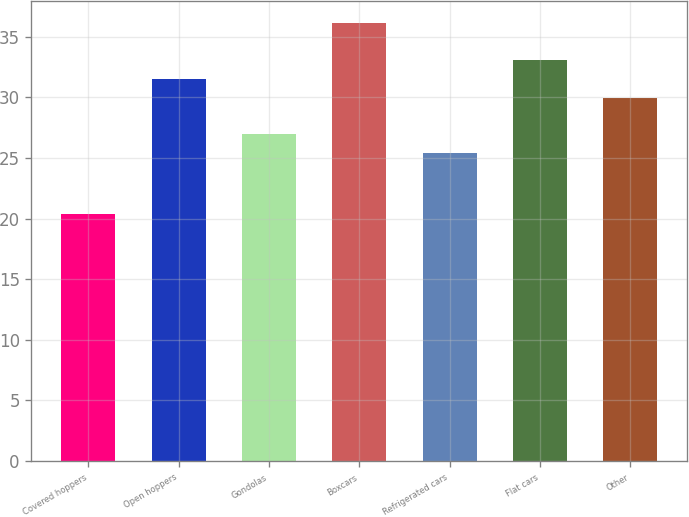Convert chart. <chart><loc_0><loc_0><loc_500><loc_500><bar_chart><fcel>Covered hoppers<fcel>Open hoppers<fcel>Gondolas<fcel>Boxcars<fcel>Refrigerated cars<fcel>Flat cars<fcel>Other<nl><fcel>20.4<fcel>31.47<fcel>26.97<fcel>36.1<fcel>25.4<fcel>33.04<fcel>29.9<nl></chart> 